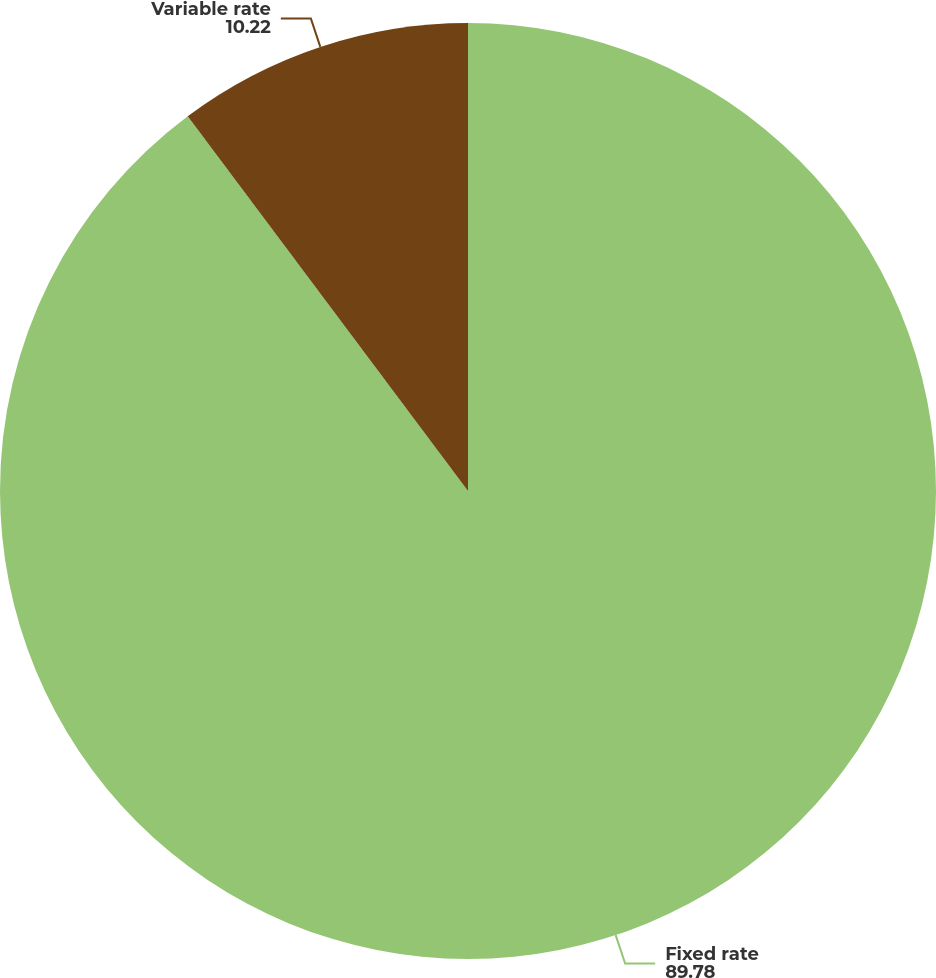<chart> <loc_0><loc_0><loc_500><loc_500><pie_chart><fcel>Fixed rate<fcel>Variable rate<nl><fcel>89.78%<fcel>10.22%<nl></chart> 